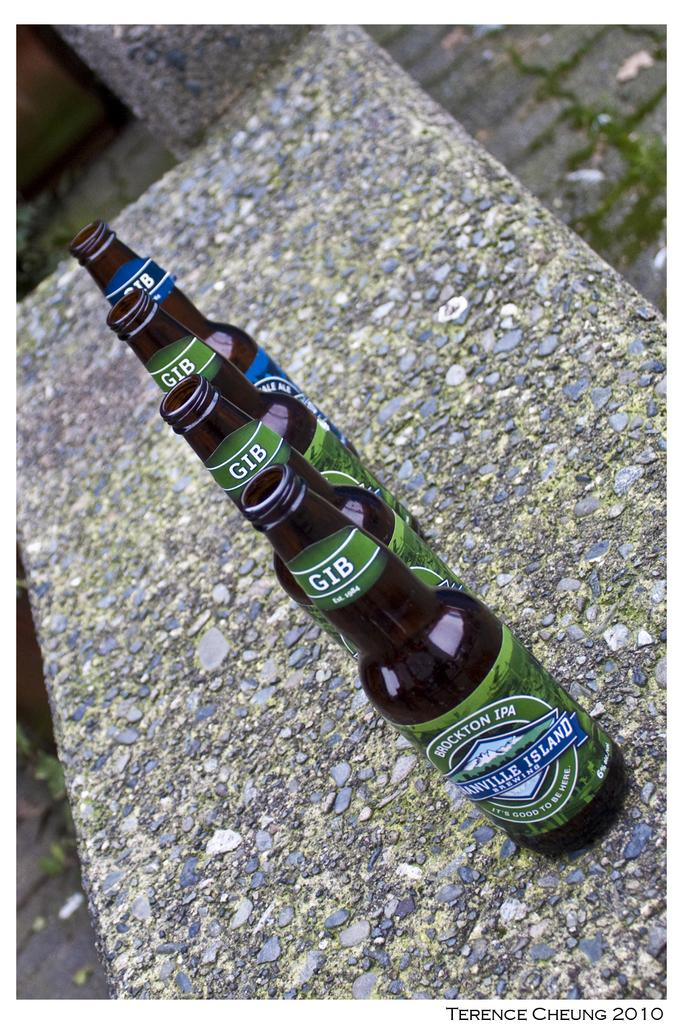<image>
Give a short and clear explanation of the subsequent image. four bottles of Brockton IPA sit in a rown on a wall. 